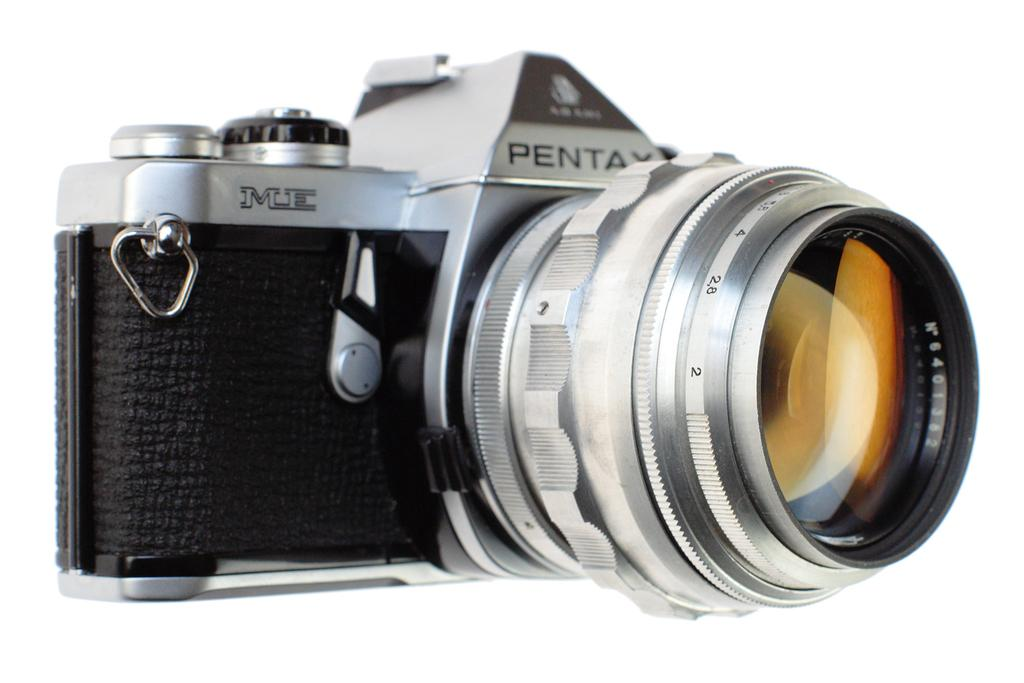What object is the main subject of the image? There is a camera in the image. Can you describe the color of the camera? The camera is black and silver. What type of ornament is hanging from the camera in the image? There is no ornament hanging from the camera in the image; it is a camera with no additional decorations. What type of plantation can be seen in the background of the image? There is no plantation visible in the image; it only features a camera. 